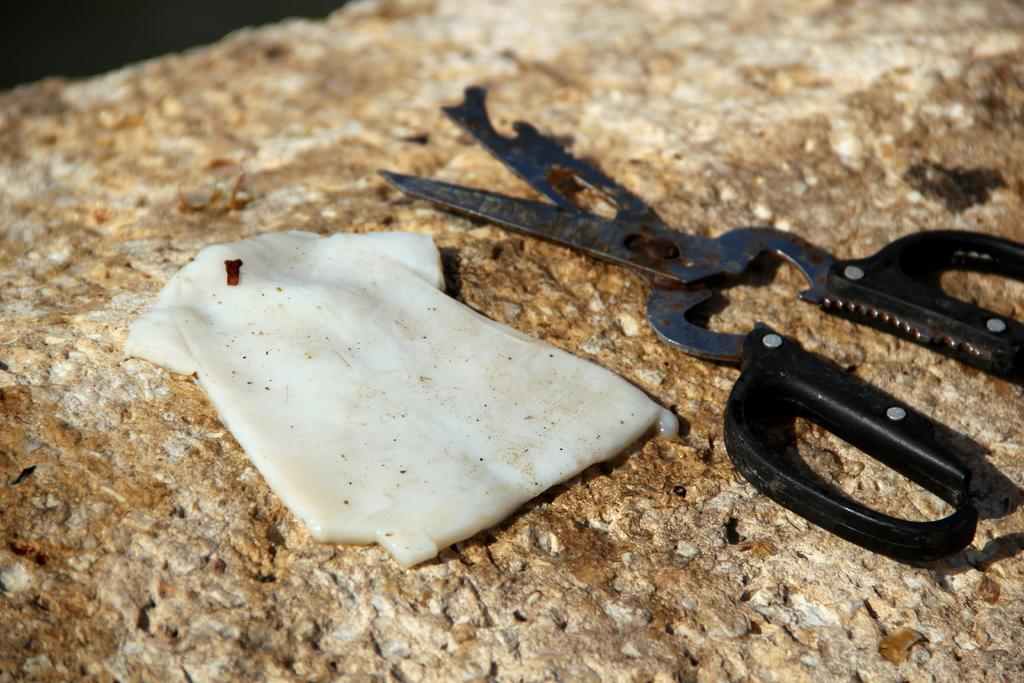What is the main subject in the image? There is an object in the image. Can you describe the object in the image? There is a pair of scissors in the image. Where are the objects located in the image? Both objects are on a surface. How many ducks are swimming in the water in the image? There are no ducks or water present in the image. What type of wire is being used to cut the cracker in the image? There is no cracker or wire present in the image. 